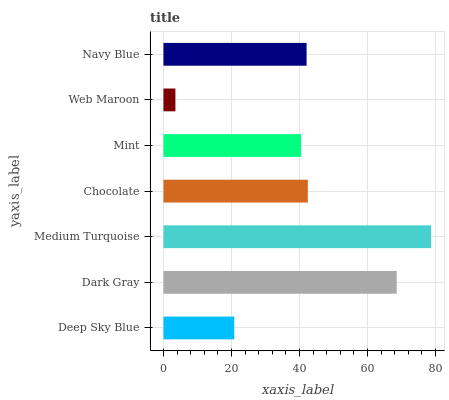Is Web Maroon the minimum?
Answer yes or no. Yes. Is Medium Turquoise the maximum?
Answer yes or no. Yes. Is Dark Gray the minimum?
Answer yes or no. No. Is Dark Gray the maximum?
Answer yes or no. No. Is Dark Gray greater than Deep Sky Blue?
Answer yes or no. Yes. Is Deep Sky Blue less than Dark Gray?
Answer yes or no. Yes. Is Deep Sky Blue greater than Dark Gray?
Answer yes or no. No. Is Dark Gray less than Deep Sky Blue?
Answer yes or no. No. Is Navy Blue the high median?
Answer yes or no. Yes. Is Navy Blue the low median?
Answer yes or no. Yes. Is Mint the high median?
Answer yes or no. No. Is Medium Turquoise the low median?
Answer yes or no. No. 